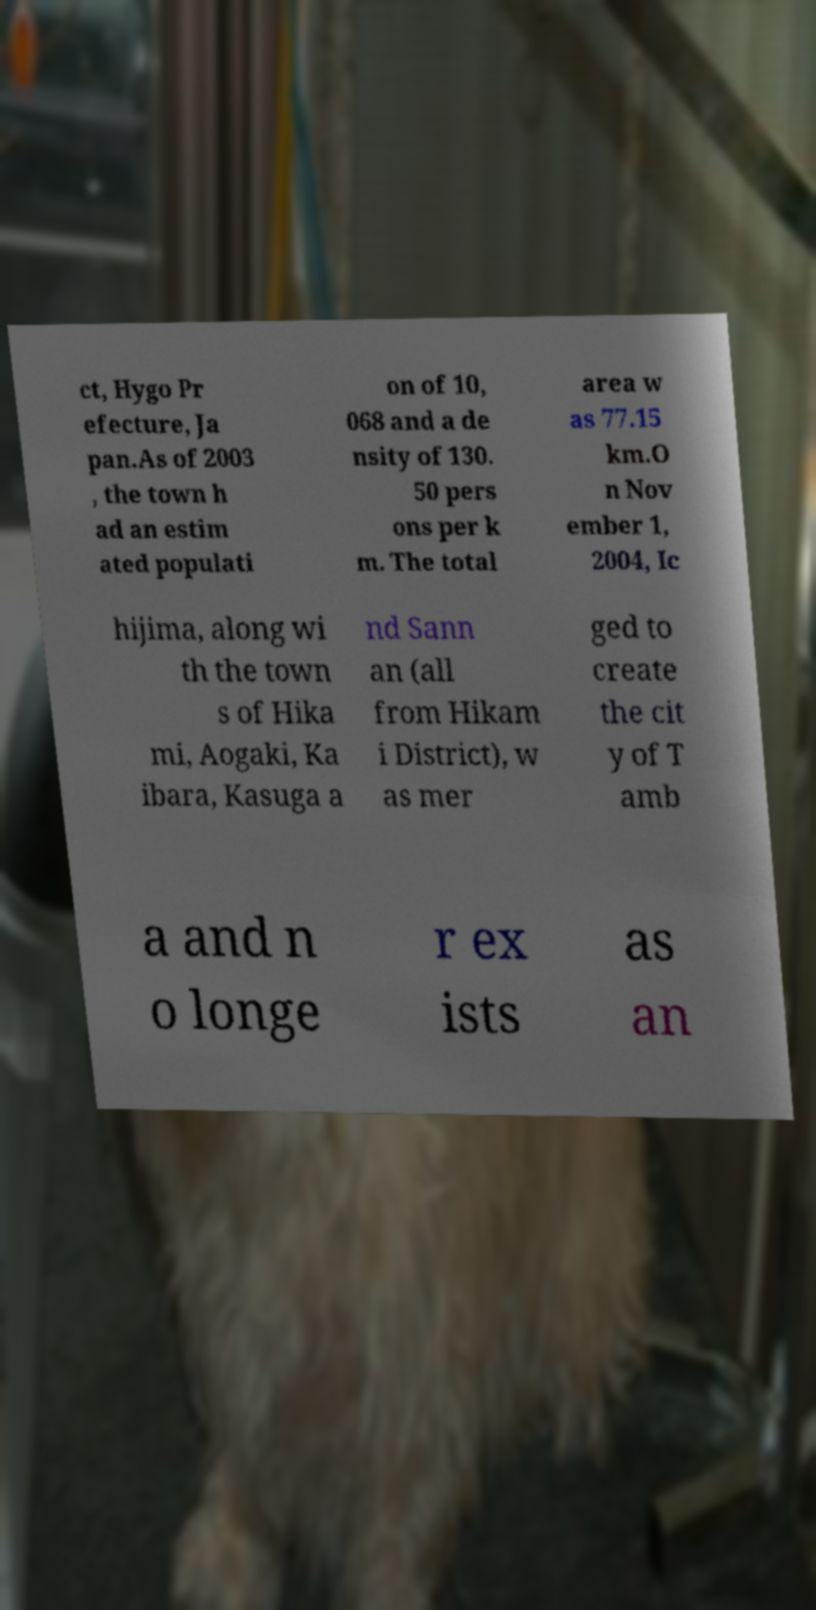Could you extract and type out the text from this image? ct, Hygo Pr efecture, Ja pan.As of 2003 , the town h ad an estim ated populati on of 10, 068 and a de nsity of 130. 50 pers ons per k m. The total area w as 77.15 km.O n Nov ember 1, 2004, Ic hijima, along wi th the town s of Hika mi, Aogaki, Ka ibara, Kasuga a nd Sann an (all from Hikam i District), w as mer ged to create the cit y of T amb a and n o longe r ex ists as an 